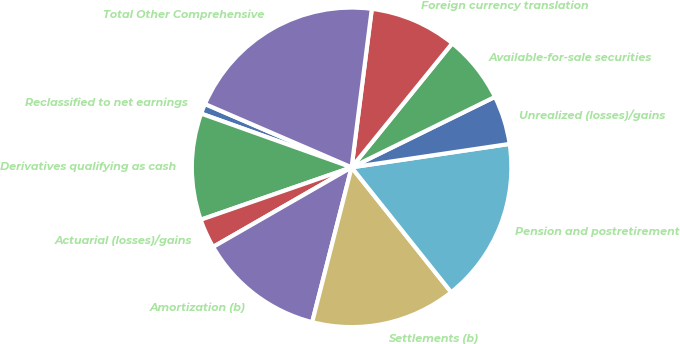Convert chart to OTSL. <chart><loc_0><loc_0><loc_500><loc_500><pie_chart><fcel>Reclassified to net earnings<fcel>Derivatives qualifying as cash<fcel>Actuarial (losses)/gains<fcel>Amortization (b)<fcel>Settlements (b)<fcel>Pension and postretirement<fcel>Unrealized (losses)/gains<fcel>Available-for-sale securities<fcel>Foreign currency translation<fcel>Total Other Comprehensive<nl><fcel>1.03%<fcel>10.78%<fcel>2.98%<fcel>12.73%<fcel>14.68%<fcel>16.63%<fcel>4.93%<fcel>6.88%<fcel>8.83%<fcel>20.53%<nl></chart> 